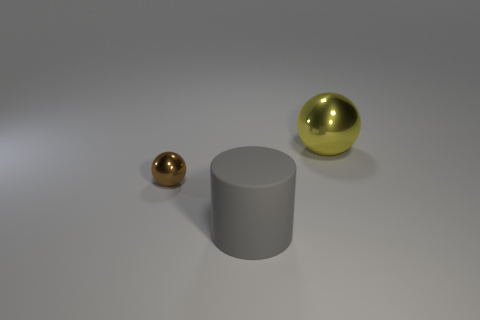Are the large thing that is in front of the brown sphere and the large yellow object made of the same material? The large object in front of the brown sphere appears to be a gray cylinder, while the large yellow object is a sphere. While both may look like they have a smooth surface in the image, we cannot definitively determine if they are made of the same material just by looking at the image. However, if we consider common characteristics of objects with similar appearances, they could both be made out of materials typically used in 3D renderings, such as digital representations of metal or plastic. 